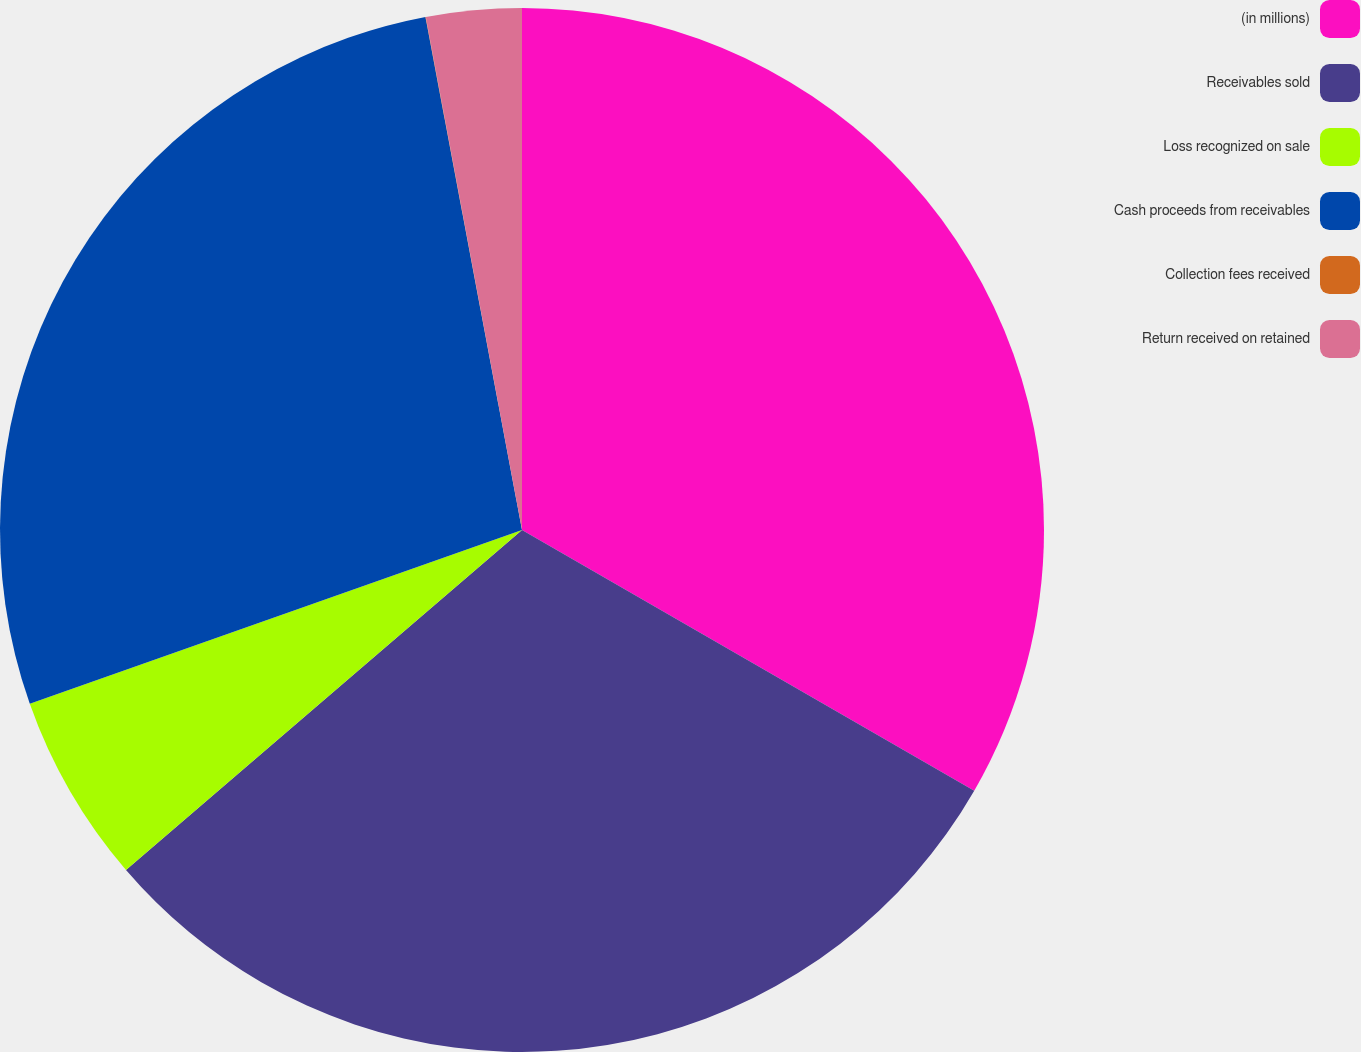Convert chart. <chart><loc_0><loc_0><loc_500><loc_500><pie_chart><fcel>(in millions)<fcel>Receivables sold<fcel>Loss recognized on sale<fcel>Cash proceeds from receivables<fcel>Collection fees received<fcel>Return received on retained<nl><fcel>33.32%<fcel>30.38%<fcel>5.89%<fcel>27.44%<fcel>0.01%<fcel>2.95%<nl></chart> 